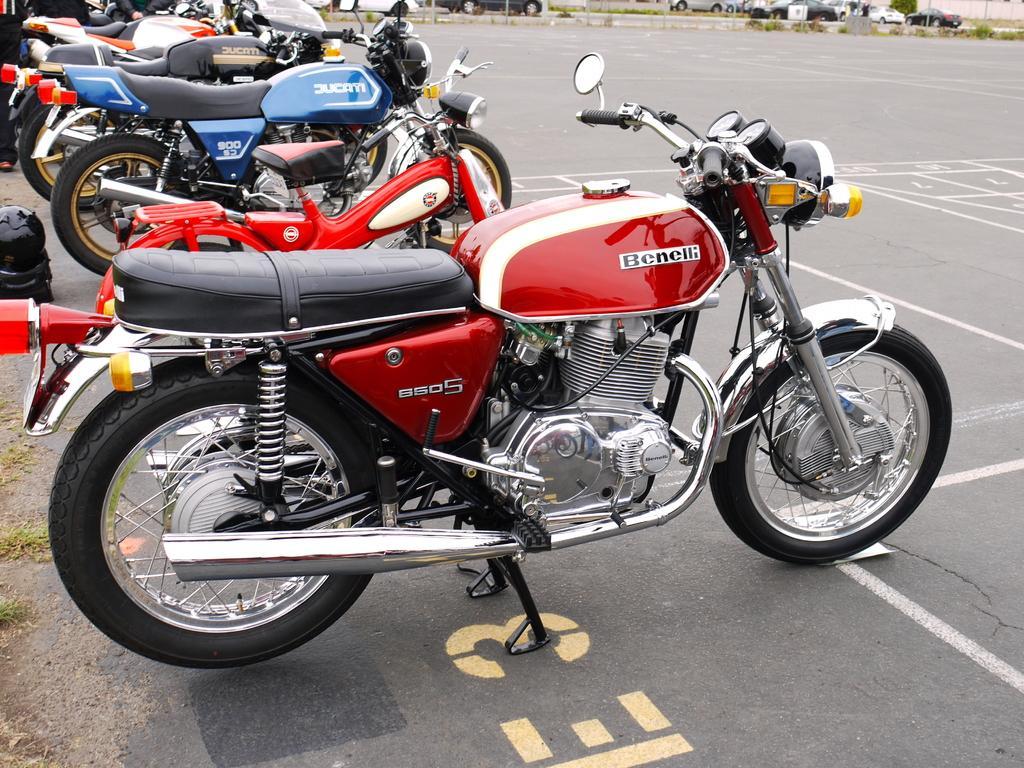Describe this image in one or two sentences. In the picture there are collection of bikes they are arranged in an order,the bikes are of different colors. 